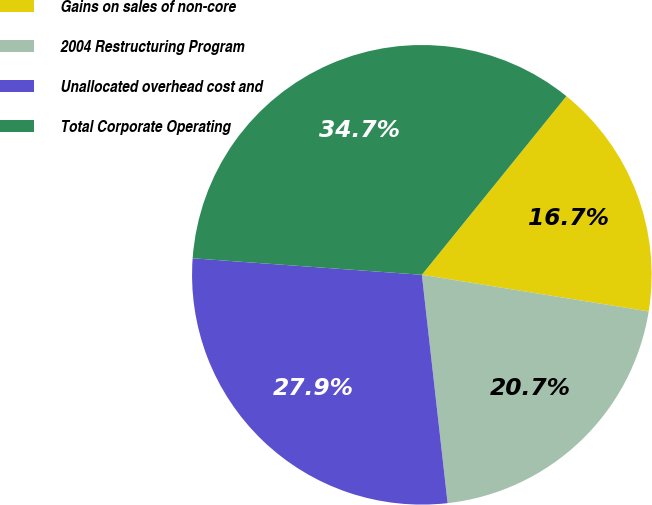<chart> <loc_0><loc_0><loc_500><loc_500><pie_chart><fcel>Gains on sales of non-core<fcel>2004 Restructuring Program<fcel>Unallocated overhead cost and<fcel>Total Corporate Operating<nl><fcel>16.72%<fcel>20.66%<fcel>27.93%<fcel>34.68%<nl></chart> 